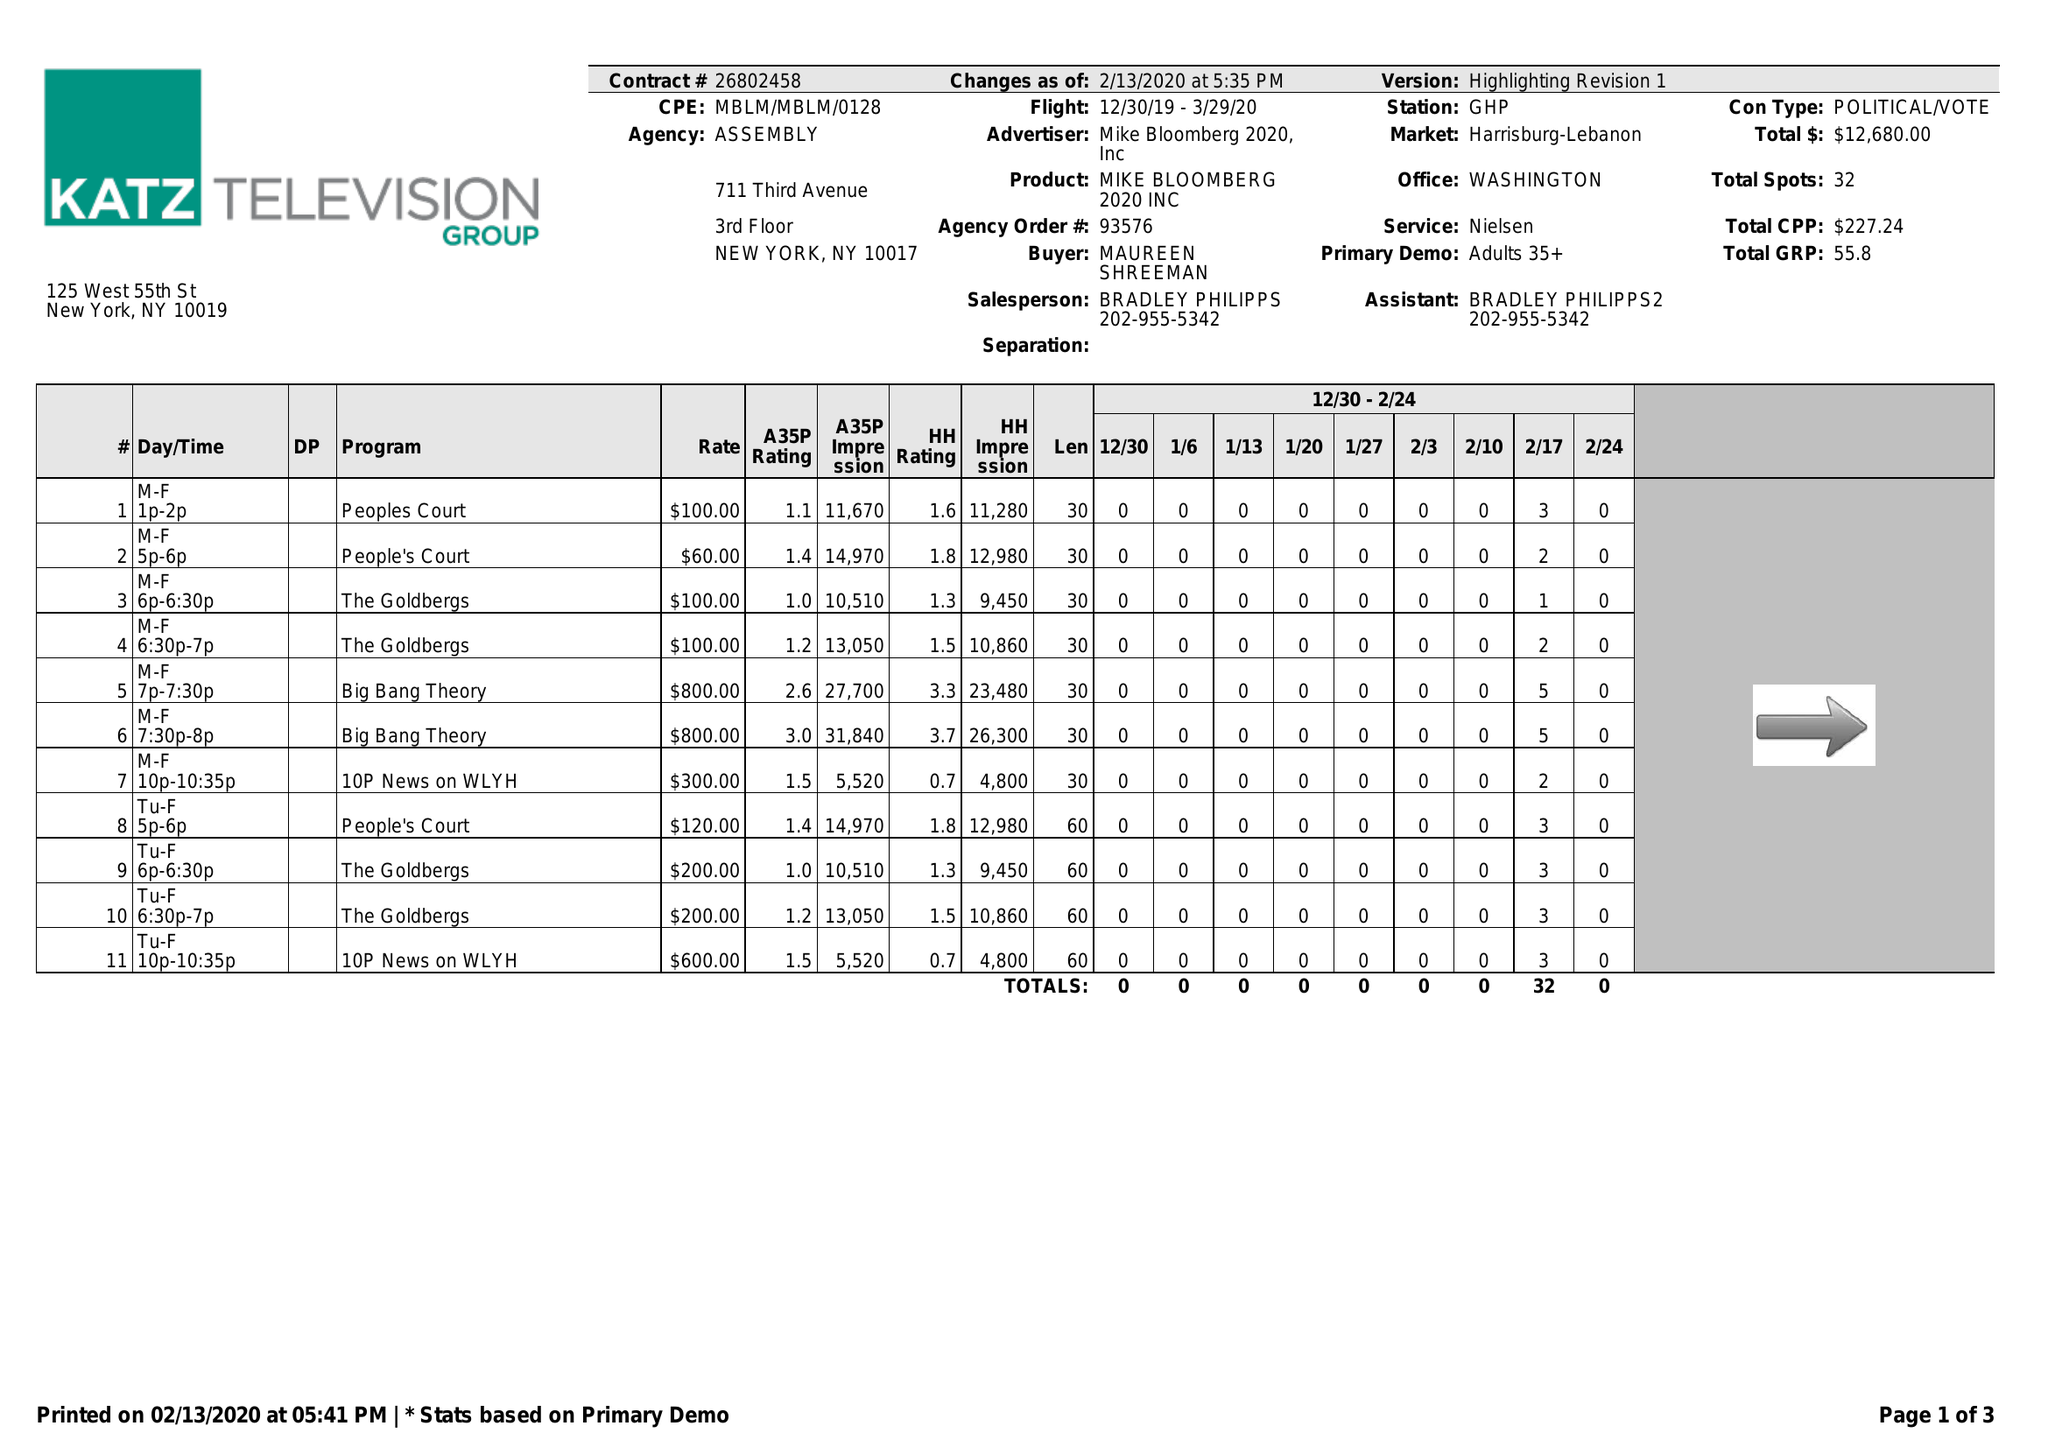What is the value for the advertiser?
Answer the question using a single word or phrase. MIKE BLOOMBERG 2020, INC 